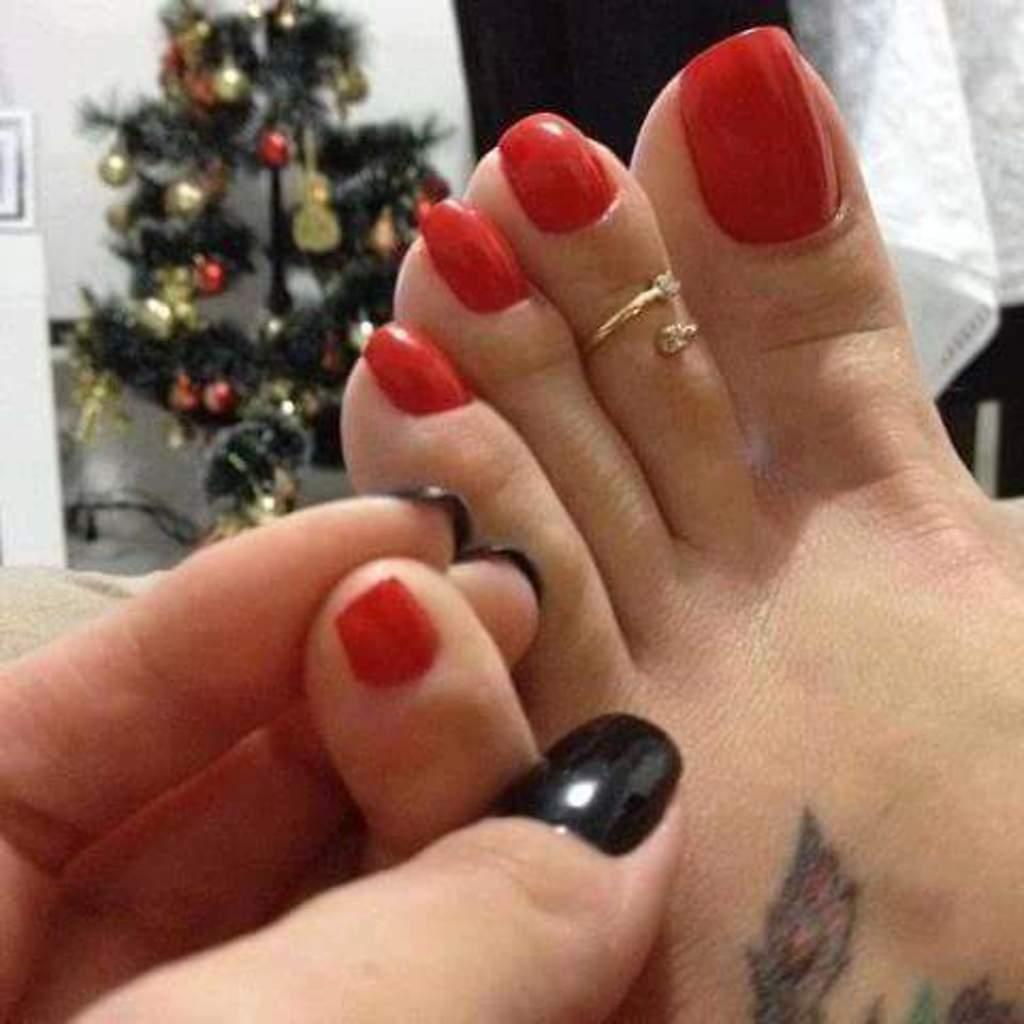Please provide a concise description of this image. In this image there are legs in the middle. There is a nail polish to the nails. In the background there is a Christmas tree to which there are balls. On the right side top there is a white cloth. On the left side bottom there is a hand which is holding the leg. 